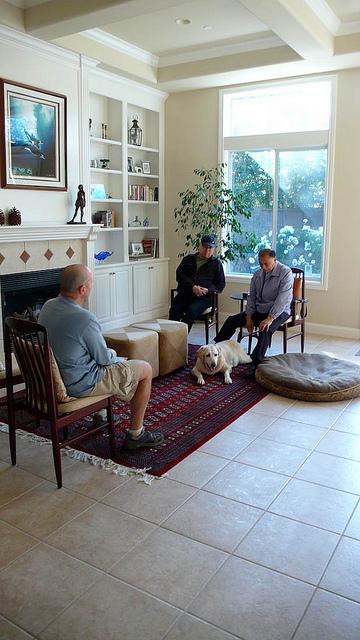Do the men look like they're fighting?
Give a very brief answer. No. Do they have a pet?
Quick response, please. Yes. Are the chairs fancy?
Short answer required. No. What is the dog doing?
Give a very brief answer. Laying down. 